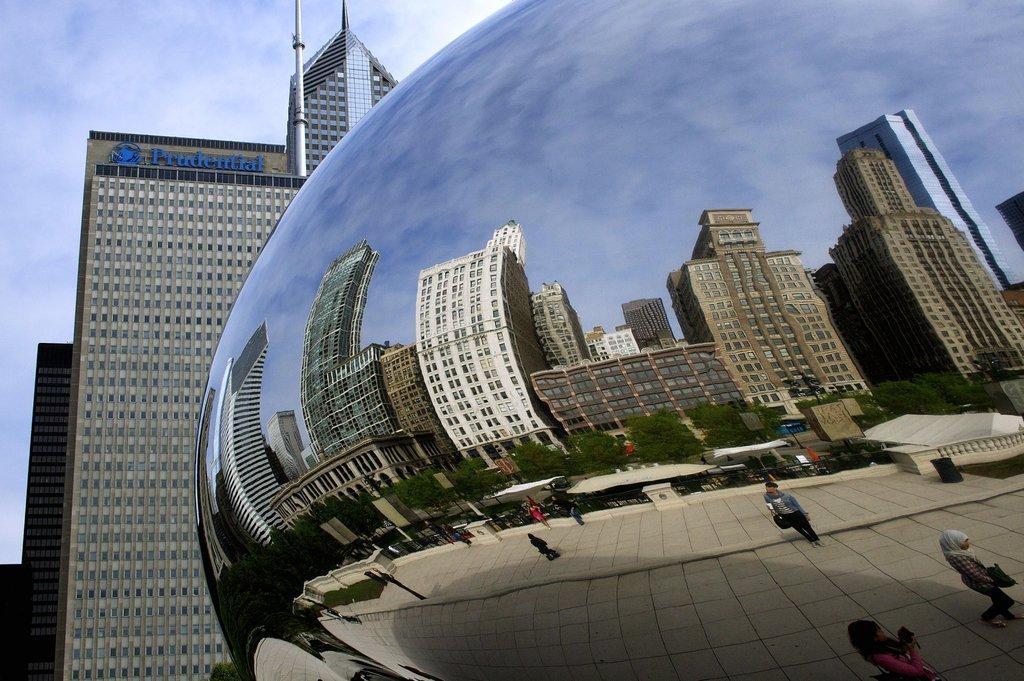Can you describe this image briefly? On the right side there is a round shape glass. On that there is a reflection of buildings, poles, trees and people. In the back there are buildings. On the building there is a name. In the background there is sky. 